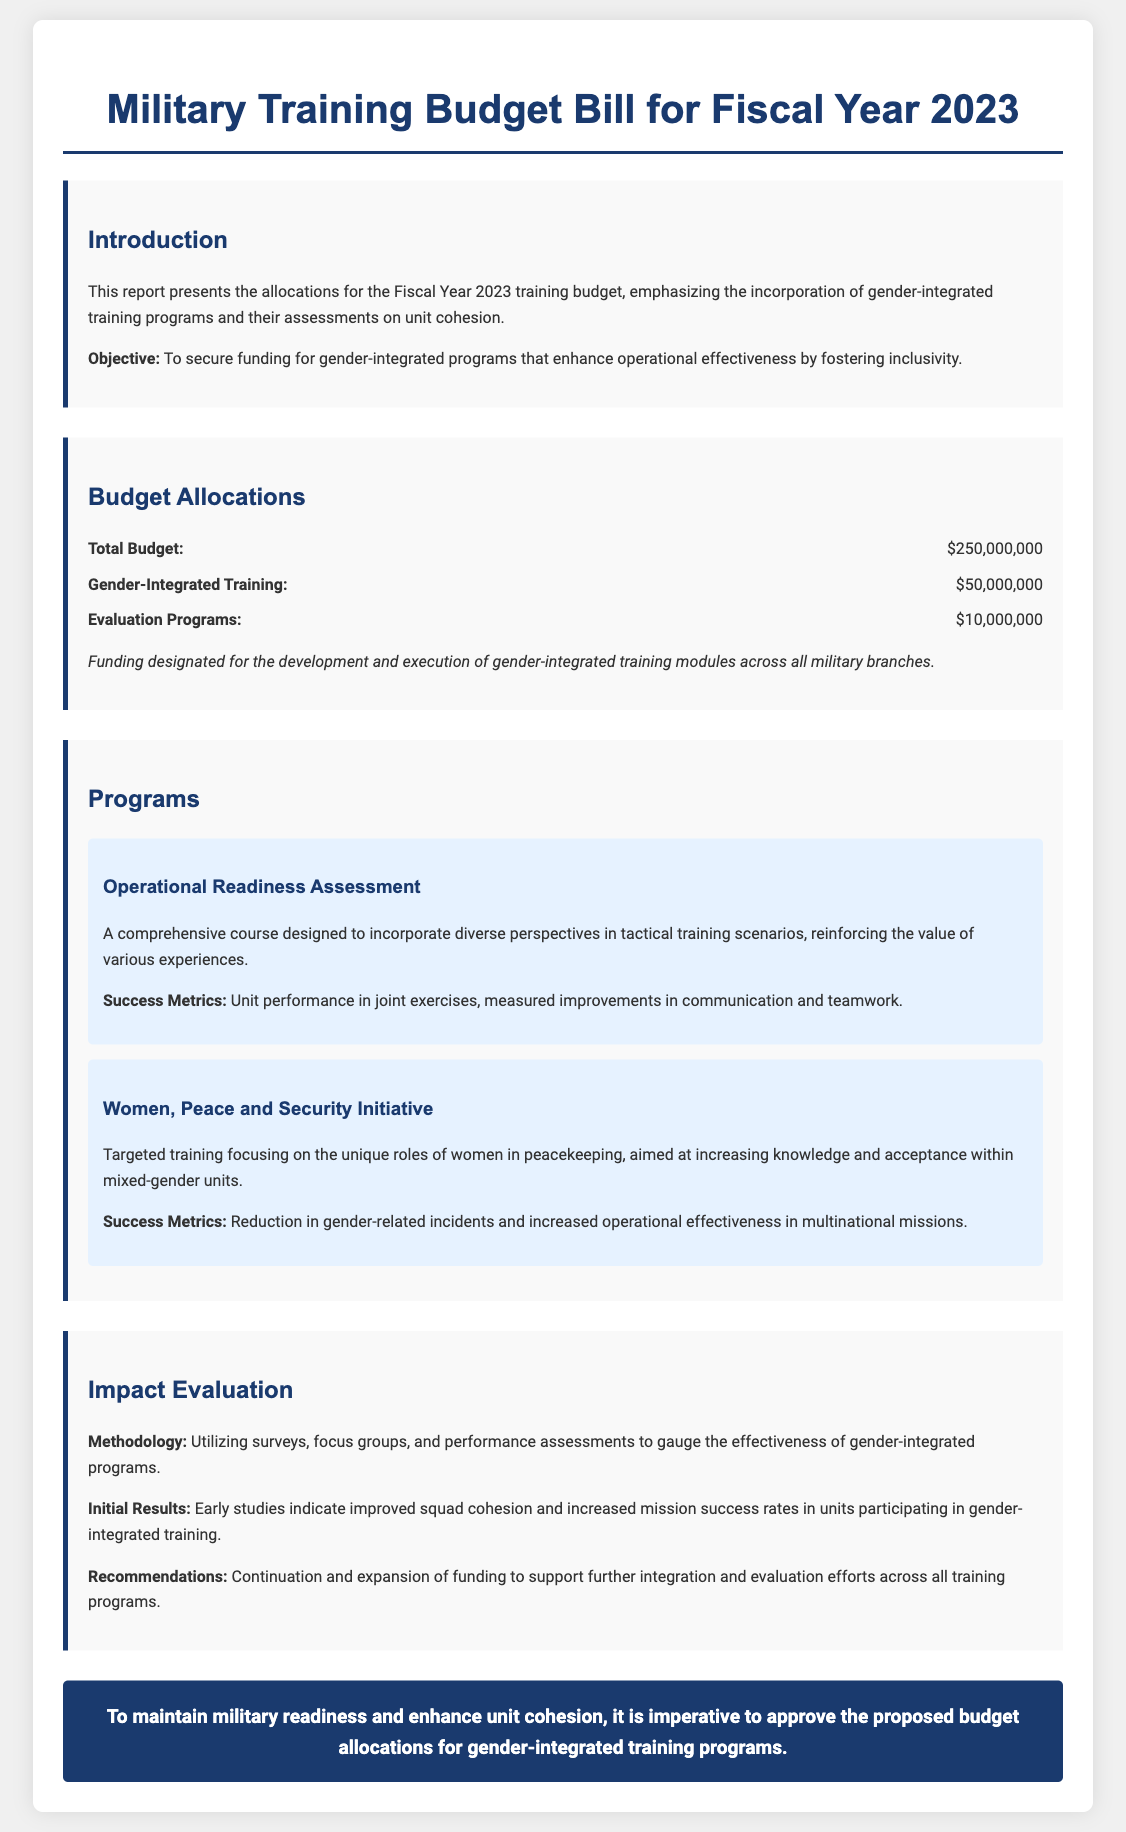What is the total budget for Fiscal Year 2023? The total budget is explicitly stated in the document under budget allocations as $250,000,000.
Answer: $250,000,000 How much is allocated for Gender-Integrated Training? The budget allocation for Gender-Integrated Training is specified as $50,000,000 in the document.
Answer: $50,000,000 What is the budget for Evaluation Programs? The document lists the budget for Evaluation Programs as $10,000,000.
Answer: $10,000,000 What is the focus of the Women, Peace and Security Initiative? The document describes the Women, Peace and Security Initiative as targeting training for the unique roles of women in peacekeeping.
Answer: Unique roles of women in peacekeeping What does the Operational Readiness Assessment aim to incorporate? According to the document, the Operational Readiness Assessment aims to incorporate diverse perspectives in tactical training scenarios.
Answer: Diverse perspectives What methodology is used for impact evaluation? The document mentions using surveys, focus groups, and performance assessments for the impact evaluation methodology.
Answer: Surveys, focus groups, and performance assessments What initial results indicate from gender-integrated training? The document states that early studies indicate improved squad cohesion and increased mission success rates.
Answer: Improved squad cohesion and increased mission success rates What is the conclusion regarding the proposed budget allocations? The conclusion in the document emphasizes the need to approve proposed budget allocations for gender-integrated training programs to enhance unit cohesion.
Answer: Approve proposed budget allocations for gender-integrated training programs 